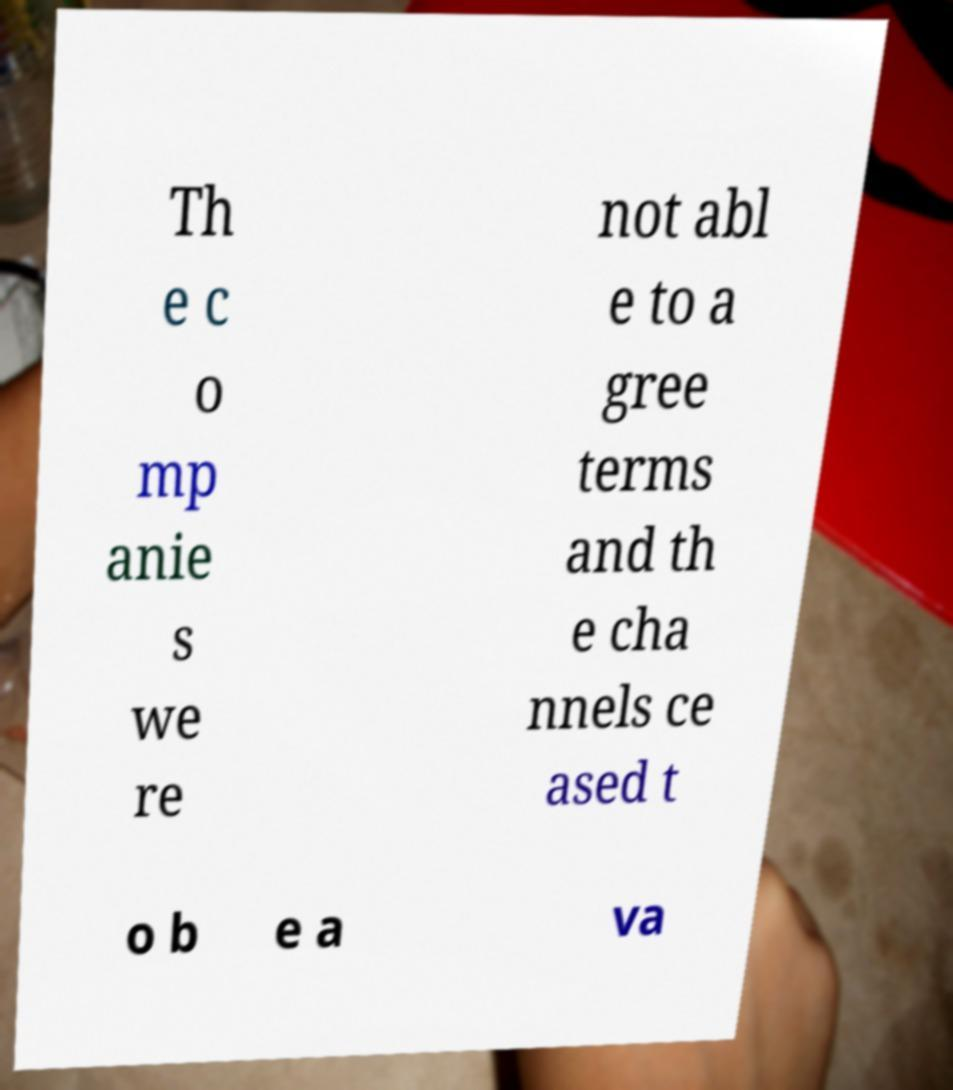Could you extract and type out the text from this image? Th e c o mp anie s we re not abl e to a gree terms and th e cha nnels ce ased t o b e a va 